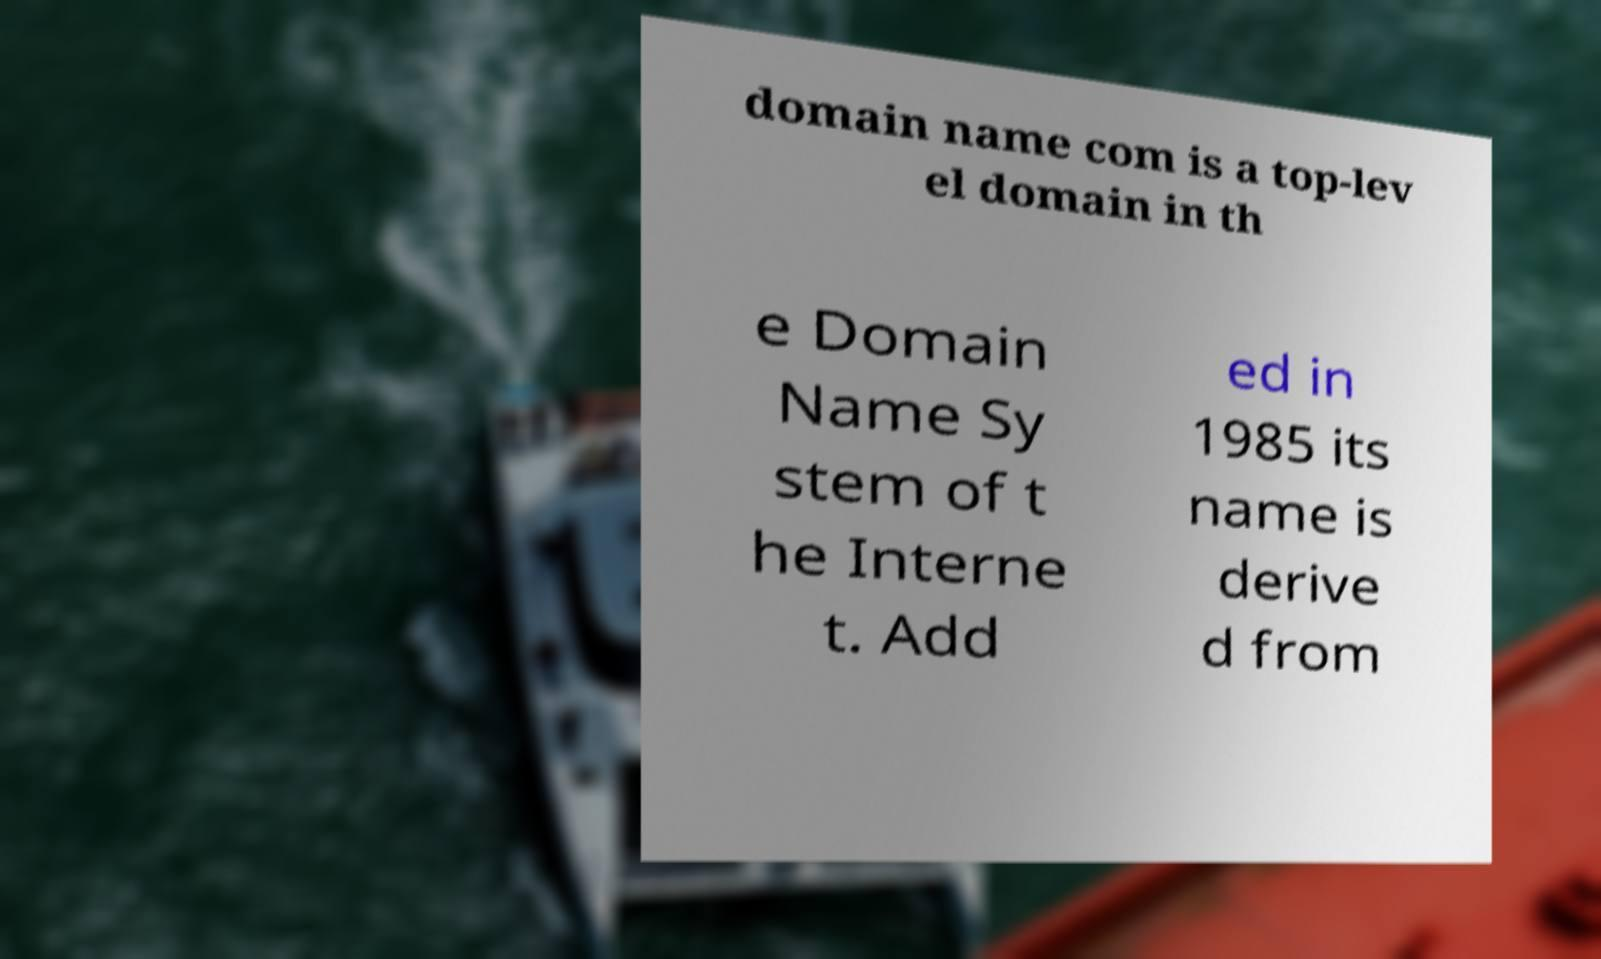For documentation purposes, I need the text within this image transcribed. Could you provide that? domain name com is a top-lev el domain in th e Domain Name Sy stem of t he Interne t. Add ed in 1985 its name is derive d from 